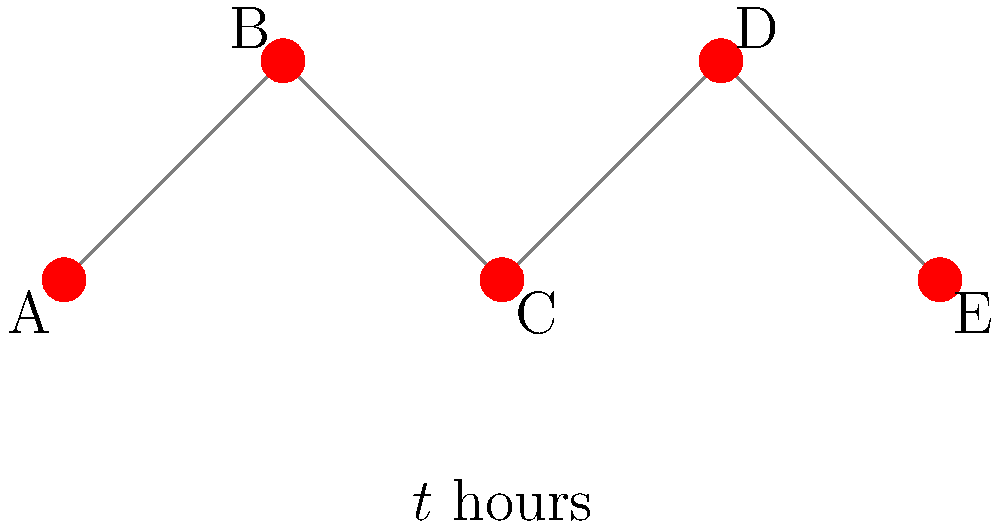In a social network, feminist ideology spreads from one person to another. The diagram represents a network of 5 individuals (A, B, C, D, and E) connected in a chain. At time $t=0$, person A starts sharing feminist ideas. The rate at which the ideology spreads is proportional to the number of people who have already adopted it, with a proportionality constant of 0.2 per hour. If we define $f(t)$ as the fraction of the network that has adopted the ideology at time $t$, find $\frac{df}{dt}$ when 60% of the network has adopted the ideology. Let's approach this step-by-step:

1) We're given that the rate of spread is proportional to the number of people who have already adopted the ideology. Mathematically, this can be expressed as:

   $$\frac{dN}{dt} = 0.2N$$

   where $N$ is the number of people who have adopted the ideology.

2) We're asked about $\frac{df}{dt}$, where $f$ is the fraction of the network that has adopted the ideology. We can relate $f$ and $N$:

   $$f = \frac{N}{5}$$ (since there are 5 people in total)

3) Using the chain rule:

   $$\frac{df}{dt} = \frac{1}{5} \cdot \frac{dN}{dt}$$

4) Substituting the expression for $\frac{dN}{dt}$ from step 1:

   $$\frac{df}{dt} = \frac{1}{5} \cdot 0.2N = 0.04N$$

5) We're asked to find $\frac{df}{dt}$ when 60% of the network has adopted the ideology. At this point:

   $$f = 0.6$$
   $$N = 5f = 5 \cdot 0.6 = 3$$

6) Substituting this into our expression for $\frac{df}{dt}$:

   $$\frac{df}{dt} = 0.04 \cdot 3 = 0.12$$

Therefore, when 60% of the network has adopted the ideology, $\frac{df}{dt} = 0.12$ per hour.
Answer: 0.12 per hour 